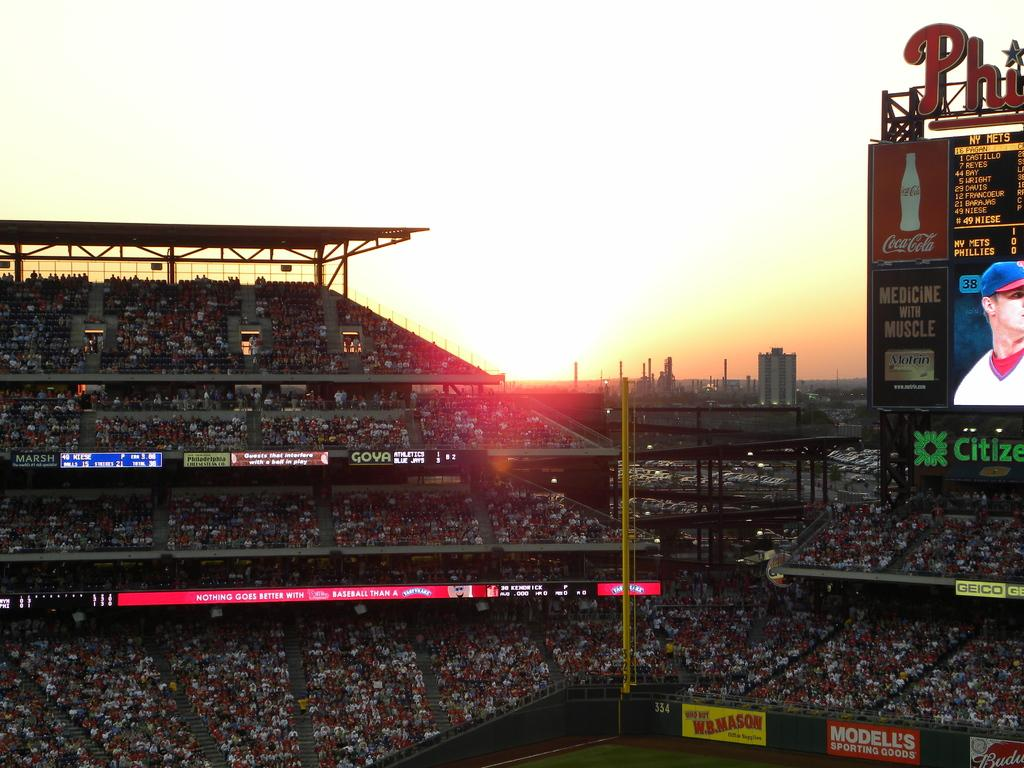<image>
Share a concise interpretation of the image provided. Stadium full of people and an ad that says Modell's sporting goods. 